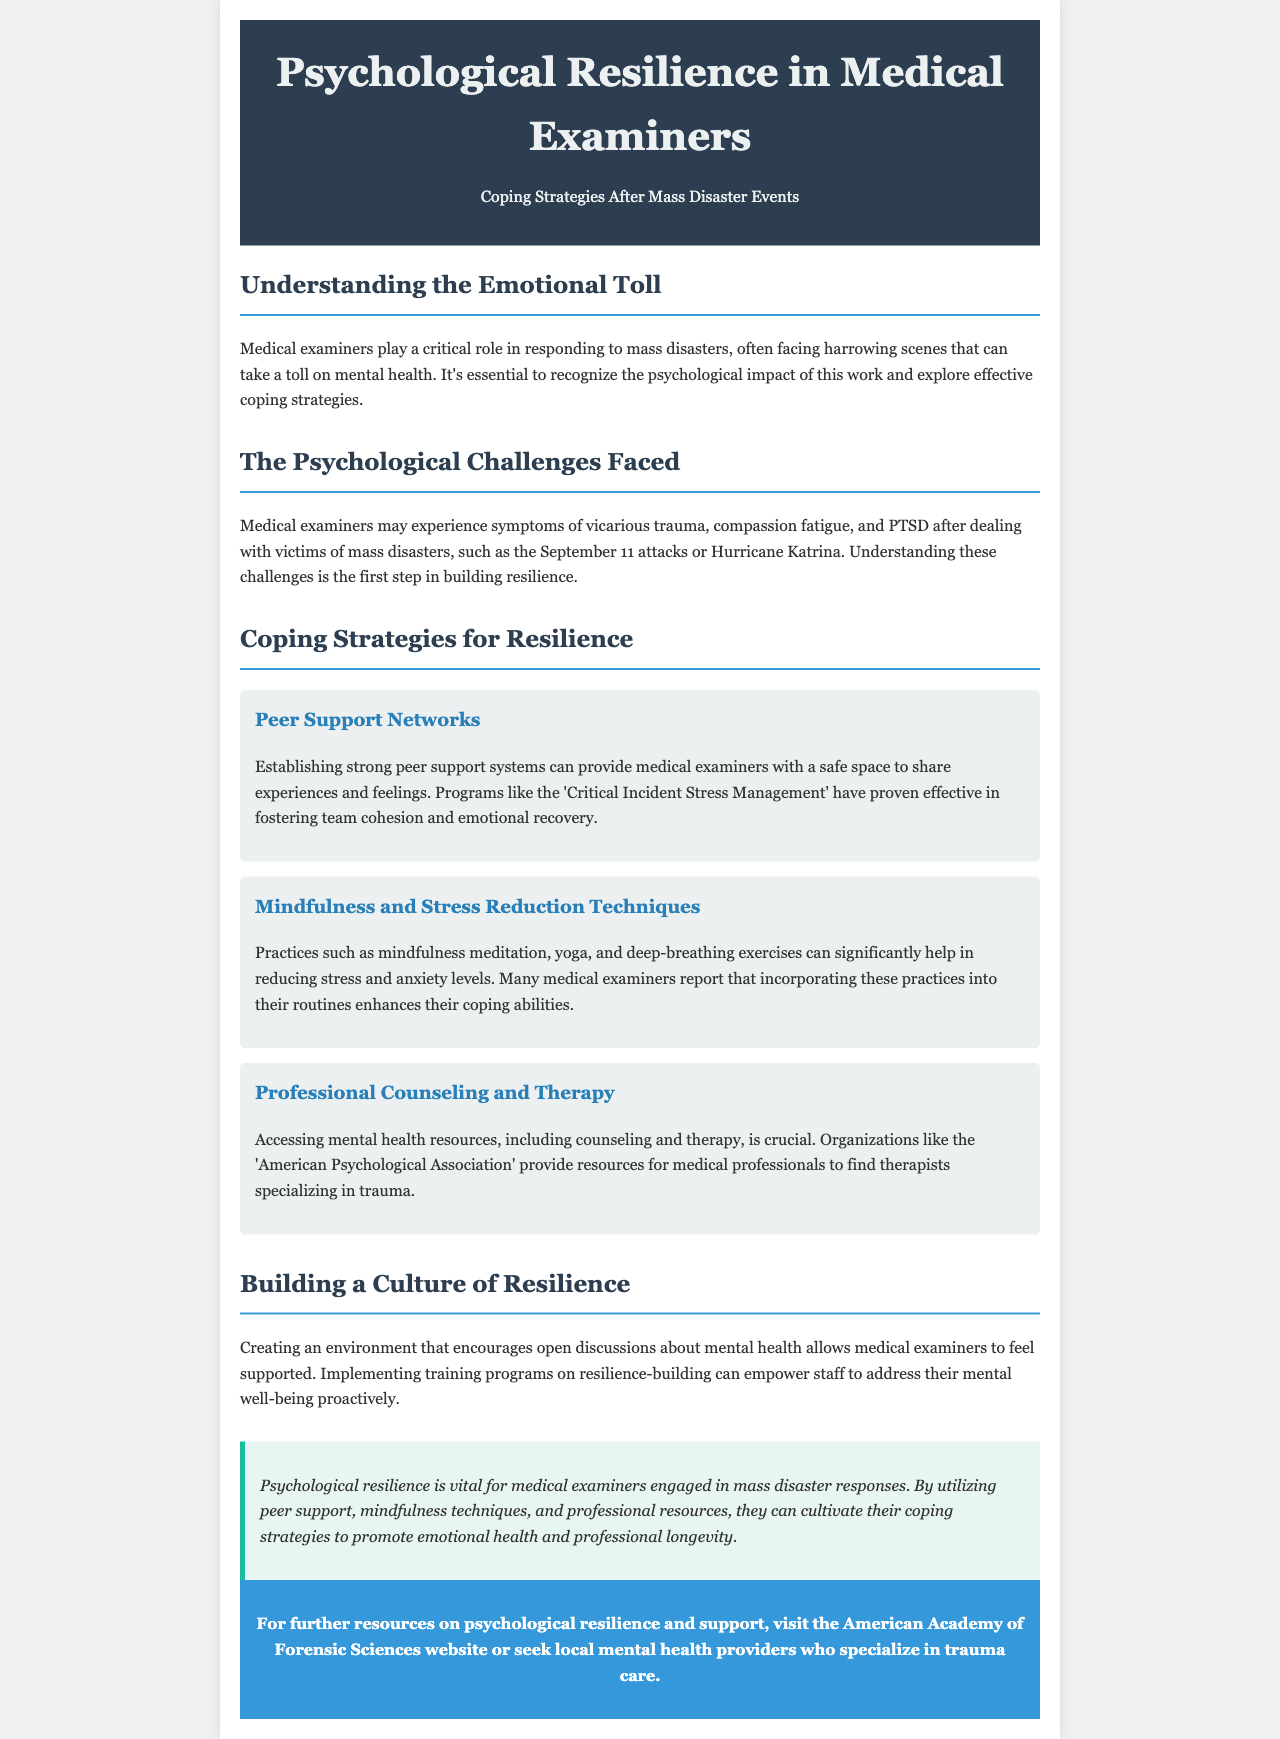What is the main focus of the newsletter? The newsletter focuses on the coping strategies of medical examiners after mass disaster events.
Answer: Coping strategies after mass disaster events What psychological challenges do medical examiners face? Medical examiners may experience vicarious trauma, compassion fatigue, and PTSD.
Answer: Vicarious trauma, compassion fatigue, PTSD Name a coping strategy mentioned for resilience. The document lists several coping strategies including peer support networks.
Answer: Peer support networks What organization provides resources for mental health support? The newsletter mentions the American Psychological Association as a resource provider.
Answer: American Psychological Association What does the subsection titled "Mindfulness and Stress Reduction Techniques" discuss? It discusses practices that help reduce stress and anxiety, such as mindfulness meditation and yoga.
Answer: Mindfulness meditation, yoga How can peer support networks benefit medical examiners? They provide a safe space for medical examiners to share experiences and feelings.
Answer: Safe space to share experiences What type of training programs can empower medical examiners? The newsletter suggests implementing resilience-building training programs for staff.
Answer: Resilience-building training programs What type of document is this? The format and content suggest it is a newsletter focused on psychological resilience in medical examiners.
Answer: Newsletter 